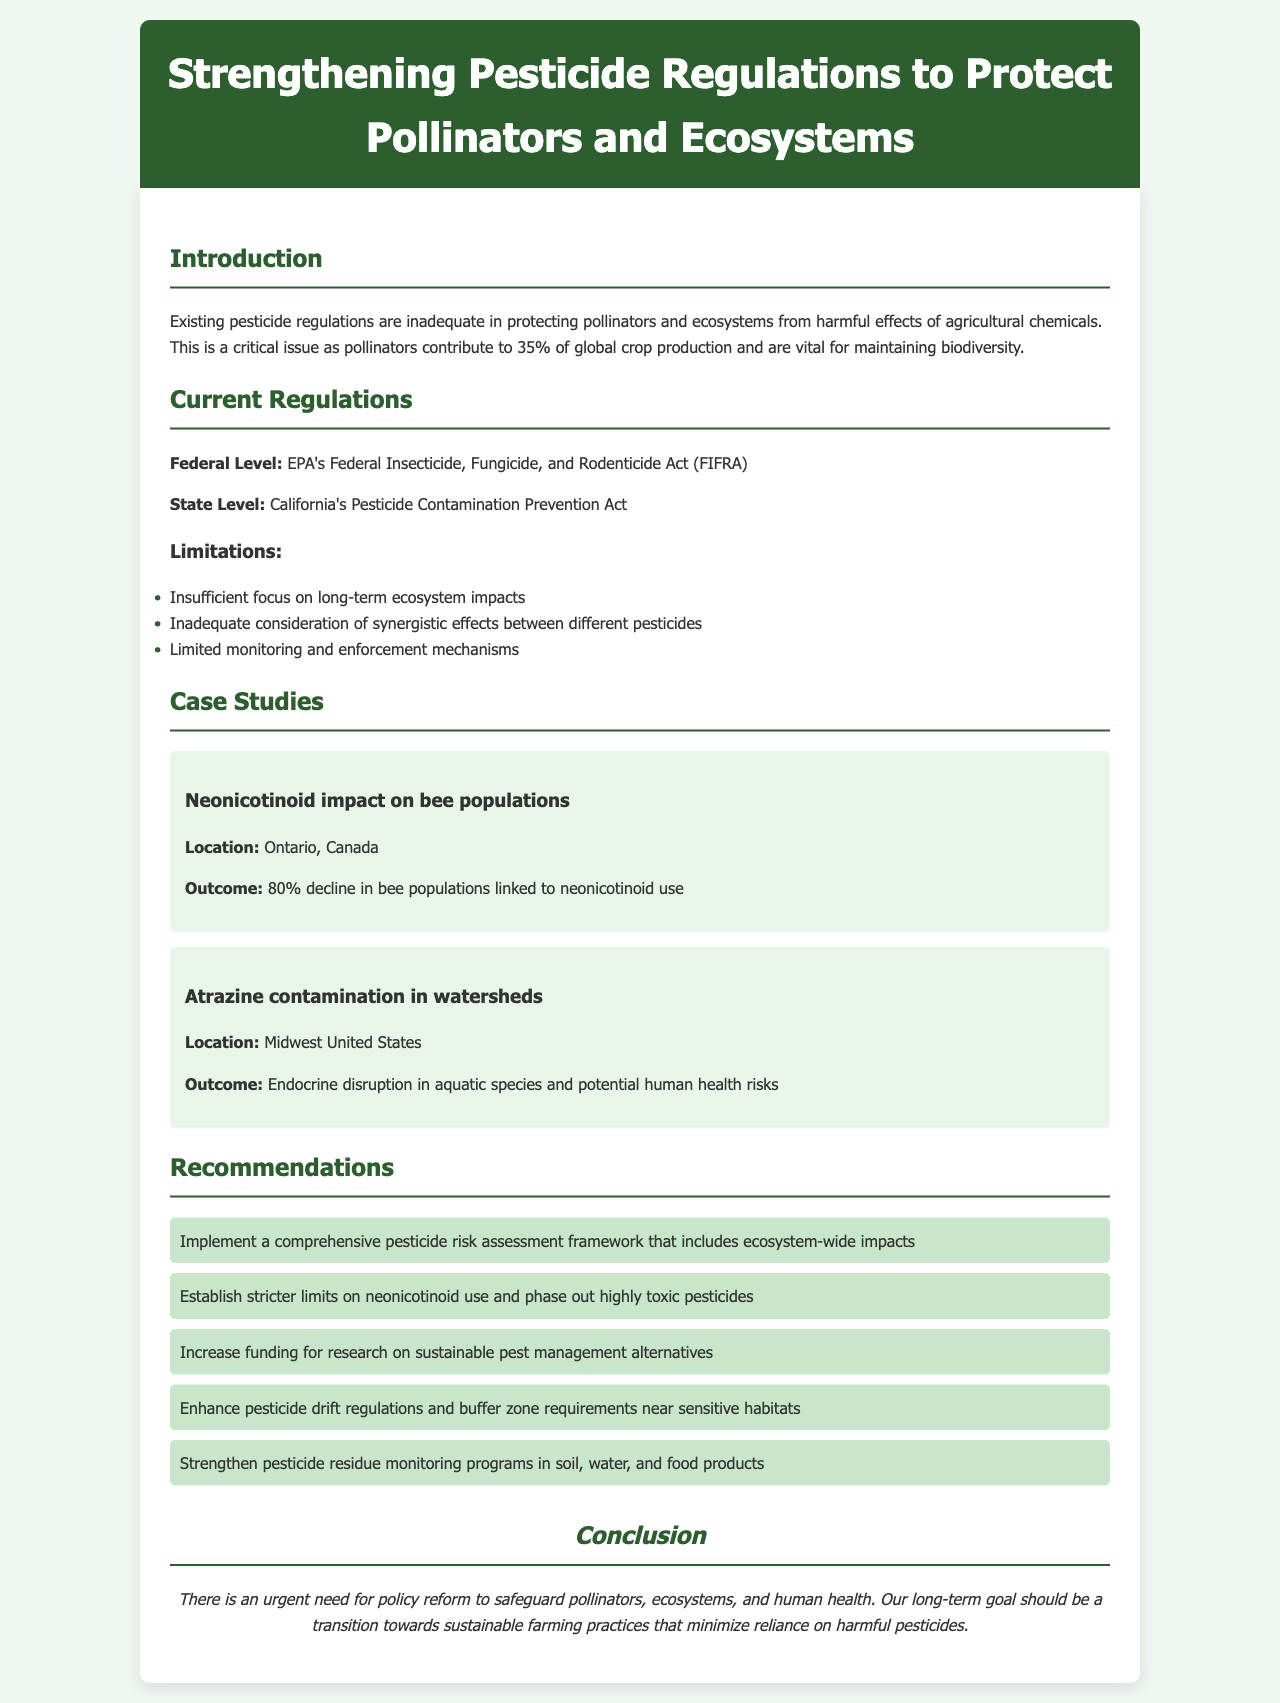What percentage of global crop production is attributed to pollinators? The document states that pollinators contribute to 35% of global crop production.
Answer: 35% What is the federal act that regulates pesticides? The regulation at the federal level is under the EPA's Federal Insecticide, Fungicide, and Rodenticide Act (FIFRA).
Answer: FIFRA What decline percentage in bee populations is linked to neonicotinoid use in Ontario? The document mentions an 80% decline in bee populations linked to neonicotinoid use.
Answer: 80% Which pesticide's use is recommended to be phased out? The recommendation includes phasing out highly toxic pesticides, specifically mentioning neonicotinoids.
Answer: Highly toxic pesticides What is one limitation of current pesticide regulations mentioned? It is noted that there is an insufficient focus on long-term ecosystem impacts.
Answer: Insufficient focus on long-term ecosystem impacts What kind of assessment framework is recommended? The document proposes implementing a comprehensive pesticide risk assessment framework that includes ecosystem-wide impacts.
Answer: Comprehensive pesticide risk assessment framework What outcome was linked to Atrazine contamination? The outcome of Atrazine contamination included endocrine disruption in aquatic species and potential human health risks.
Answer: Endocrine disruption in aquatic species What is the final goal mentioned in the conclusion? The conclusion cites the long-term goal as a transition towards sustainable farming practices.
Answer: Sustainable farming practices 